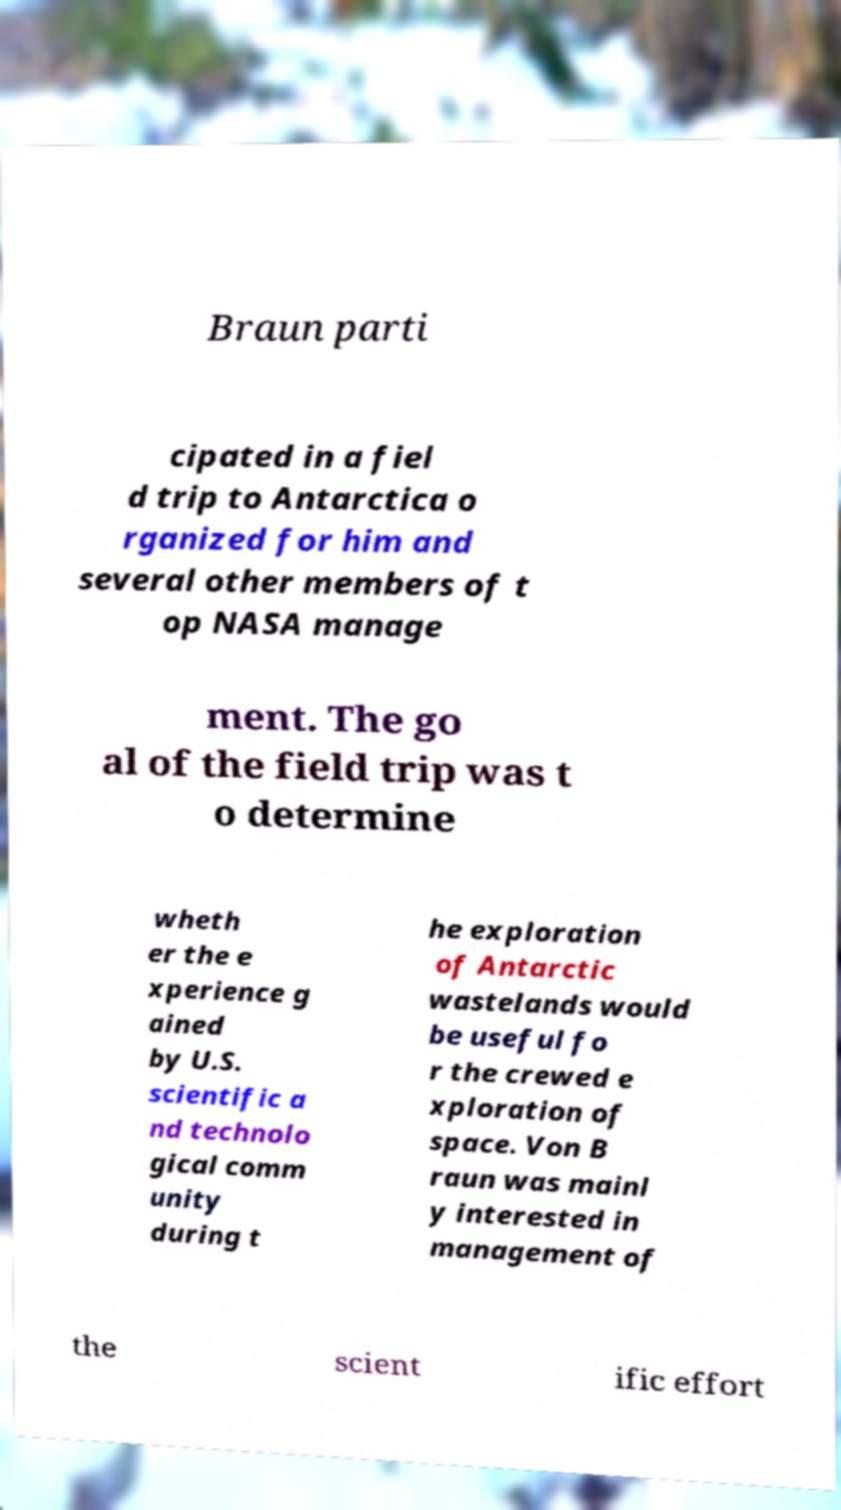There's text embedded in this image that I need extracted. Can you transcribe it verbatim? Braun parti cipated in a fiel d trip to Antarctica o rganized for him and several other members of t op NASA manage ment. The go al of the field trip was t o determine wheth er the e xperience g ained by U.S. scientific a nd technolo gical comm unity during t he exploration of Antarctic wastelands would be useful fo r the crewed e xploration of space. Von B raun was mainl y interested in management of the scient ific effort 